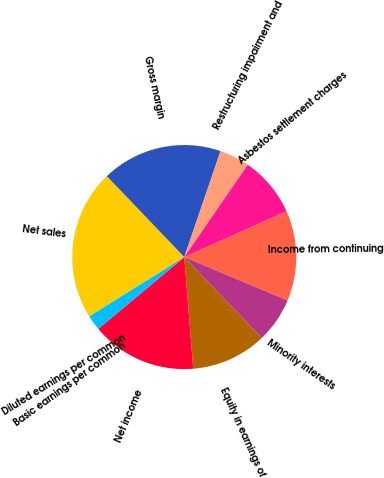<chart> <loc_0><loc_0><loc_500><loc_500><pie_chart><fcel>Net sales<fcel>Gross margin<fcel>Restructuring impairment and<fcel>Asbestos settlement charges<fcel>Income from continuing<fcel>Minority interests<fcel>Equity in earnings of<fcel>Net income<fcel>Basic earnings per common<fcel>Diluted earnings per common<nl><fcel>21.73%<fcel>17.39%<fcel>4.35%<fcel>8.7%<fcel>13.04%<fcel>6.52%<fcel>10.87%<fcel>15.21%<fcel>2.18%<fcel>0.0%<nl></chart> 